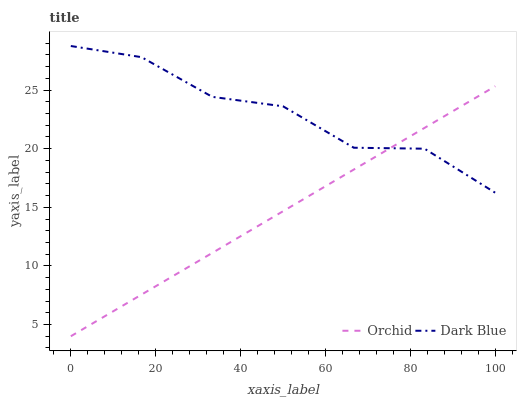Does Orchid have the minimum area under the curve?
Answer yes or no. Yes. Does Dark Blue have the maximum area under the curve?
Answer yes or no. Yes. Does Orchid have the maximum area under the curve?
Answer yes or no. No. Is Orchid the smoothest?
Answer yes or no. Yes. Is Dark Blue the roughest?
Answer yes or no. Yes. Is Orchid the roughest?
Answer yes or no. No. Does Orchid have the highest value?
Answer yes or no. No. 